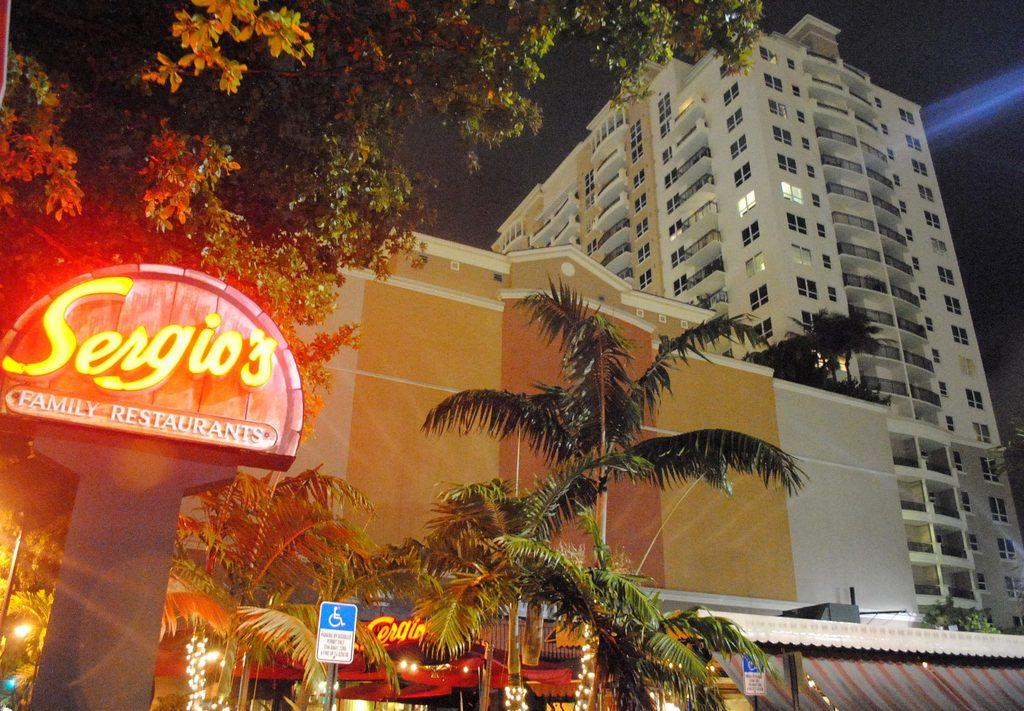What type of vegetation can be seen in the image? There are trees in the image. What are the tall, thin structures in the image? There are poles in the image. What are the flat, rectangular objects in the image? There are boards in the image. What are the illuminating objects in the image? There are lights in the image. What type of man-made structures are present in the image? There are buildings in the image. What is the color of the background in the image? The background of the image is dark. Who is the expert in the image? There is no expert present in the image. What type of feast is being held in the image? There is no feast present in the image. What type of curtain can be seen in the image? There is no curtain present in the image. 